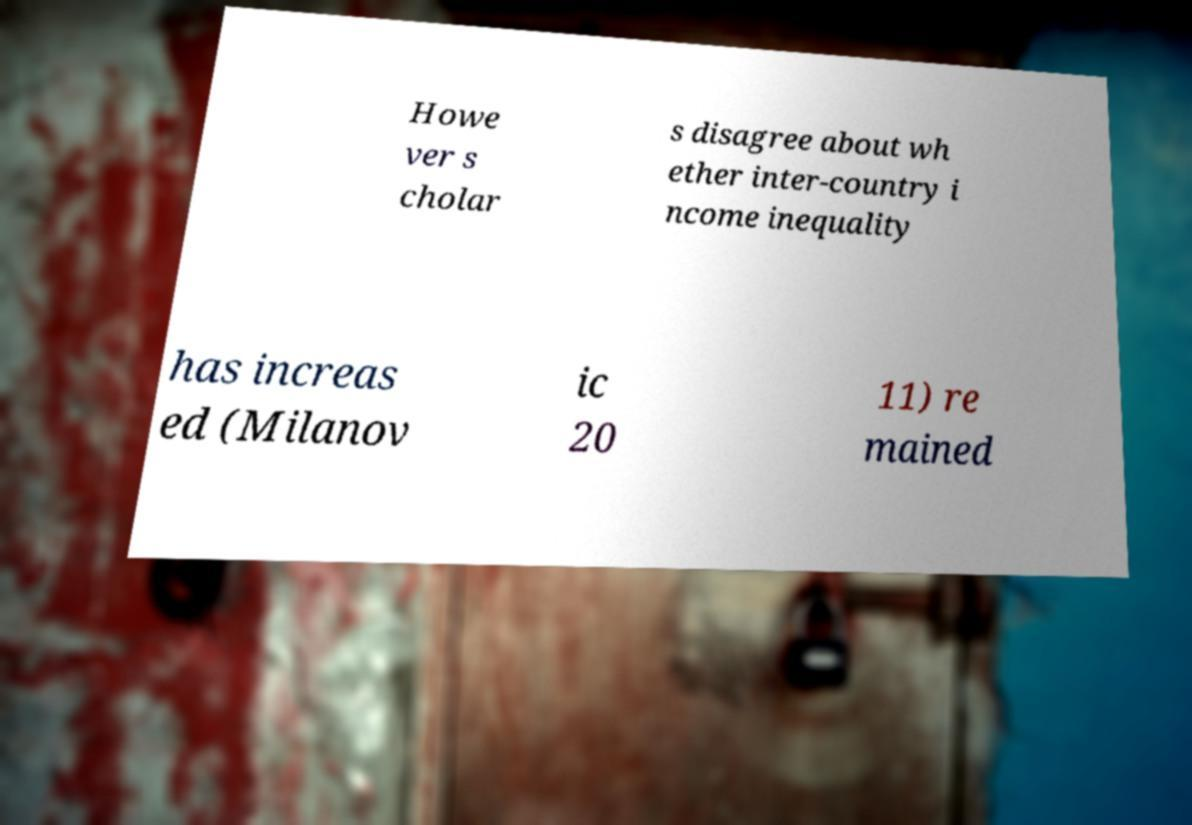What messages or text are displayed in this image? I need them in a readable, typed format. Howe ver s cholar s disagree about wh ether inter-country i ncome inequality has increas ed (Milanov ic 20 11) re mained 